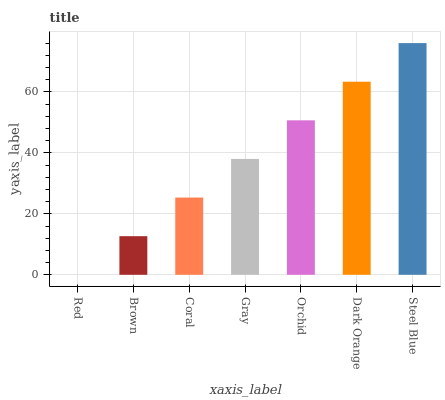Is Red the minimum?
Answer yes or no. Yes. Is Steel Blue the maximum?
Answer yes or no. Yes. Is Brown the minimum?
Answer yes or no. No. Is Brown the maximum?
Answer yes or no. No. Is Brown greater than Red?
Answer yes or no. Yes. Is Red less than Brown?
Answer yes or no. Yes. Is Red greater than Brown?
Answer yes or no. No. Is Brown less than Red?
Answer yes or no. No. Is Gray the high median?
Answer yes or no. Yes. Is Gray the low median?
Answer yes or no. Yes. Is Brown the high median?
Answer yes or no. No. Is Brown the low median?
Answer yes or no. No. 